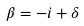<formula> <loc_0><loc_0><loc_500><loc_500>\beta = - i + \delta</formula> 